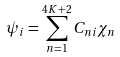Convert formula to latex. <formula><loc_0><loc_0><loc_500><loc_500>\psi _ { i } = \sum _ { n = 1 } ^ { 4 K + 2 } C _ { n i } \chi _ { n }</formula> 